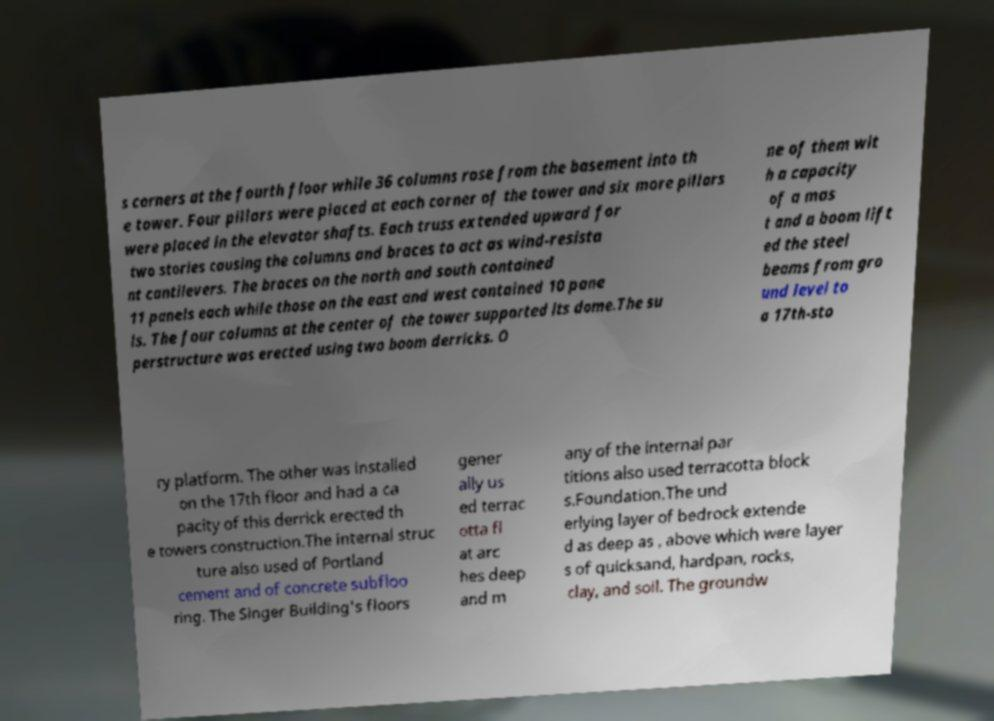What messages or text are displayed in this image? I need them in a readable, typed format. s corners at the fourth floor while 36 columns rose from the basement into th e tower. Four pillars were placed at each corner of the tower and six more pillars were placed in the elevator shafts. Each truss extended upward for two stories causing the columns and braces to act as wind-resista nt cantilevers. The braces on the north and south contained 11 panels each while those on the east and west contained 10 pane ls. The four columns at the center of the tower supported its dome.The su perstructure was erected using two boom derricks. O ne of them wit h a capacity of a mas t and a boom lift ed the steel beams from gro und level to a 17th-sto ry platform. The other was installed on the 17th floor and had a ca pacity of this derrick erected th e towers construction.The internal struc ture also used of Portland cement and of concrete subfloo ring. The Singer Building's floors gener ally us ed terrac otta fl at arc hes deep and m any of the internal par titions also used terracotta block s.Foundation.The und erlying layer of bedrock extende d as deep as , above which were layer s of quicksand, hardpan, rocks, clay, and soil. The groundw 